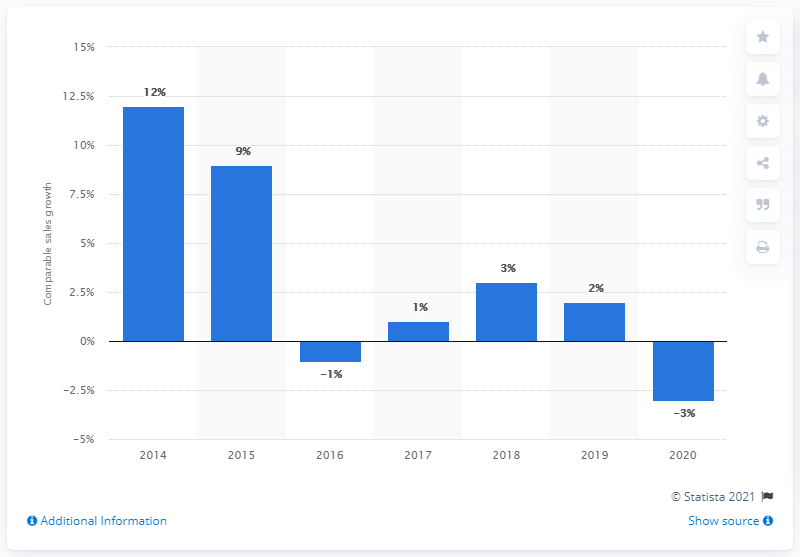Point out several critical features in this image. In 2020, Burberry's comparable sales decreased by 3%. 